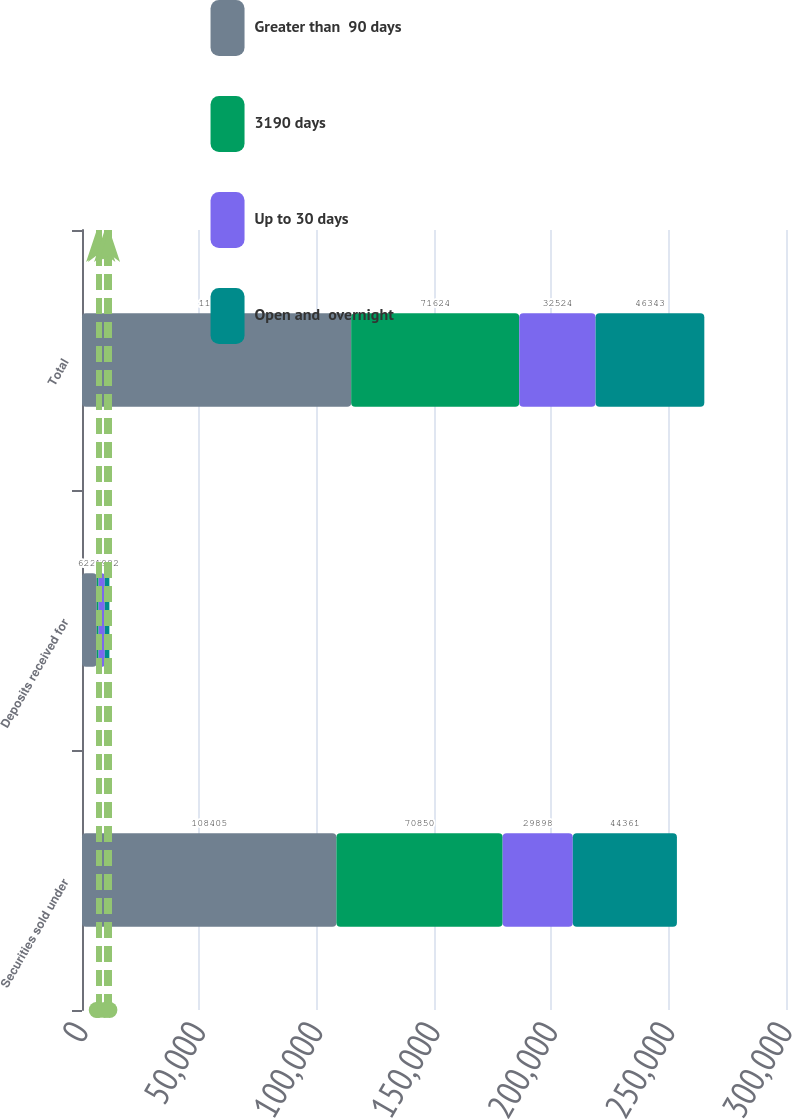<chart> <loc_0><loc_0><loc_500><loc_500><stacked_bar_chart><ecel><fcel>Securities sold under<fcel>Deposits received for<fcel>Total<nl><fcel>Greater than  90 days<fcel>108405<fcel>6296<fcel>114701<nl><fcel>3190 days<fcel>70850<fcel>774<fcel>71624<nl><fcel>Up to 30 days<fcel>29898<fcel>2626<fcel>32524<nl><fcel>Open and  overnight<fcel>44361<fcel>1982<fcel>46343<nl></chart> 